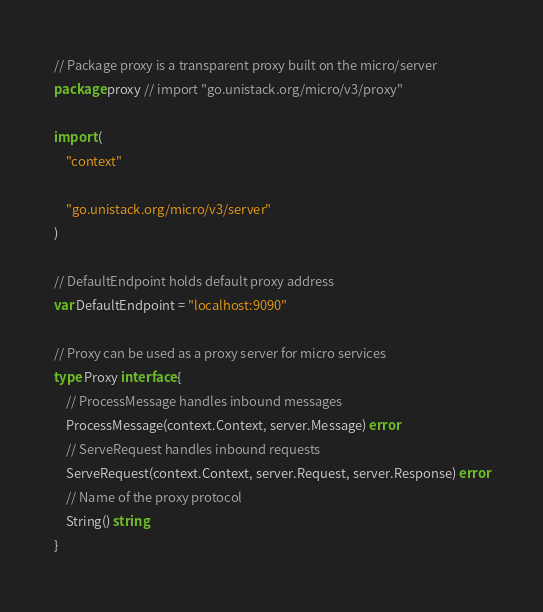Convert code to text. <code><loc_0><loc_0><loc_500><loc_500><_Go_>// Package proxy is a transparent proxy built on the micro/server
package proxy // import "go.unistack.org/micro/v3/proxy"

import (
	"context"

	"go.unistack.org/micro/v3/server"
)

// DefaultEndpoint holds default proxy address
var DefaultEndpoint = "localhost:9090"

// Proxy can be used as a proxy server for micro services
type Proxy interface {
	// ProcessMessage handles inbound messages
	ProcessMessage(context.Context, server.Message) error
	// ServeRequest handles inbound requests
	ServeRequest(context.Context, server.Request, server.Response) error
	// Name of the proxy protocol
	String() string
}
</code> 